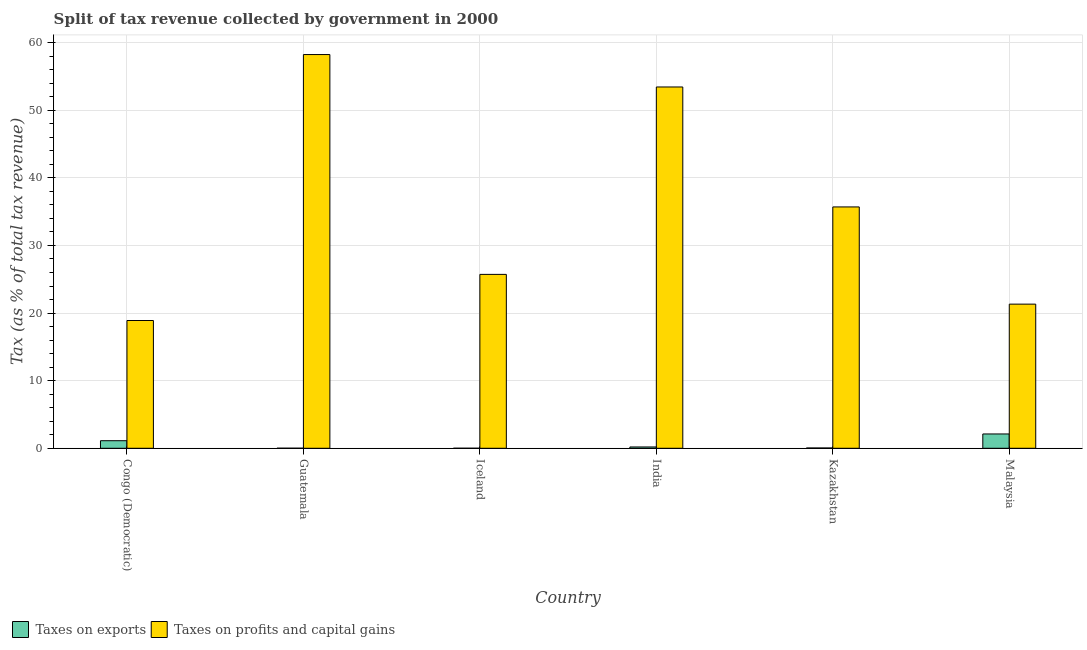Are the number of bars on each tick of the X-axis equal?
Give a very brief answer. Yes. How many bars are there on the 1st tick from the left?
Give a very brief answer. 2. What is the label of the 1st group of bars from the left?
Make the answer very short. Congo (Democratic). In how many cases, is the number of bars for a given country not equal to the number of legend labels?
Provide a short and direct response. 0. What is the percentage of revenue obtained from taxes on profits and capital gains in Kazakhstan?
Make the answer very short. 35.7. Across all countries, what is the maximum percentage of revenue obtained from taxes on profits and capital gains?
Your answer should be compact. 58.24. Across all countries, what is the minimum percentage of revenue obtained from taxes on profits and capital gains?
Your response must be concise. 18.9. In which country was the percentage of revenue obtained from taxes on profits and capital gains maximum?
Provide a succinct answer. Guatemala. In which country was the percentage of revenue obtained from taxes on profits and capital gains minimum?
Your response must be concise. Congo (Democratic). What is the total percentage of revenue obtained from taxes on profits and capital gains in the graph?
Your response must be concise. 213.34. What is the difference between the percentage of revenue obtained from taxes on exports in Guatemala and that in India?
Offer a terse response. -0.19. What is the difference between the percentage of revenue obtained from taxes on profits and capital gains in Kazakhstan and the percentage of revenue obtained from taxes on exports in Iceland?
Your response must be concise. 35.7. What is the average percentage of revenue obtained from taxes on exports per country?
Offer a very short reply. 0.58. What is the difference between the percentage of revenue obtained from taxes on profits and capital gains and percentage of revenue obtained from taxes on exports in Congo (Democratic)?
Keep it short and to the point. 17.78. What is the ratio of the percentage of revenue obtained from taxes on profits and capital gains in India to that in Kazakhstan?
Provide a short and direct response. 1.5. Is the difference between the percentage of revenue obtained from taxes on profits and capital gains in Guatemala and Malaysia greater than the difference between the percentage of revenue obtained from taxes on exports in Guatemala and Malaysia?
Give a very brief answer. Yes. What is the difference between the highest and the second highest percentage of revenue obtained from taxes on exports?
Ensure brevity in your answer.  1. What is the difference between the highest and the lowest percentage of revenue obtained from taxes on exports?
Provide a short and direct response. 2.11. What does the 2nd bar from the left in Iceland represents?
Give a very brief answer. Taxes on profits and capital gains. What does the 2nd bar from the right in Kazakhstan represents?
Ensure brevity in your answer.  Taxes on exports. What is the difference between two consecutive major ticks on the Y-axis?
Give a very brief answer. 10. Are the values on the major ticks of Y-axis written in scientific E-notation?
Offer a very short reply. No. Does the graph contain grids?
Provide a short and direct response. Yes. Where does the legend appear in the graph?
Your answer should be compact. Bottom left. How many legend labels are there?
Give a very brief answer. 2. How are the legend labels stacked?
Keep it short and to the point. Horizontal. What is the title of the graph?
Make the answer very short. Split of tax revenue collected by government in 2000. What is the label or title of the Y-axis?
Your answer should be compact. Tax (as % of total tax revenue). What is the Tax (as % of total tax revenue) of Taxes on exports in Congo (Democratic)?
Provide a succinct answer. 1.12. What is the Tax (as % of total tax revenue) in Taxes on profits and capital gains in Congo (Democratic)?
Provide a succinct answer. 18.9. What is the Tax (as % of total tax revenue) in Taxes on exports in Guatemala?
Offer a terse response. 0.01. What is the Tax (as % of total tax revenue) in Taxes on profits and capital gains in Guatemala?
Provide a short and direct response. 58.24. What is the Tax (as % of total tax revenue) in Taxes on exports in Iceland?
Keep it short and to the point. 0.01. What is the Tax (as % of total tax revenue) in Taxes on profits and capital gains in Iceland?
Your response must be concise. 25.72. What is the Tax (as % of total tax revenue) in Taxes on exports in India?
Provide a succinct answer. 0.2. What is the Tax (as % of total tax revenue) of Taxes on profits and capital gains in India?
Your response must be concise. 53.45. What is the Tax (as % of total tax revenue) of Taxes on exports in Kazakhstan?
Offer a very short reply. 0.05. What is the Tax (as % of total tax revenue) in Taxes on profits and capital gains in Kazakhstan?
Your response must be concise. 35.7. What is the Tax (as % of total tax revenue) of Taxes on exports in Malaysia?
Make the answer very short. 2.12. What is the Tax (as % of total tax revenue) of Taxes on profits and capital gains in Malaysia?
Make the answer very short. 21.32. Across all countries, what is the maximum Tax (as % of total tax revenue) of Taxes on exports?
Keep it short and to the point. 2.12. Across all countries, what is the maximum Tax (as % of total tax revenue) in Taxes on profits and capital gains?
Your answer should be very brief. 58.24. Across all countries, what is the minimum Tax (as % of total tax revenue) of Taxes on exports?
Provide a succinct answer. 0.01. Across all countries, what is the minimum Tax (as % of total tax revenue) in Taxes on profits and capital gains?
Provide a succinct answer. 18.9. What is the total Tax (as % of total tax revenue) of Taxes on exports in the graph?
Give a very brief answer. 3.5. What is the total Tax (as % of total tax revenue) of Taxes on profits and capital gains in the graph?
Make the answer very short. 213.34. What is the difference between the Tax (as % of total tax revenue) of Taxes on exports in Congo (Democratic) and that in Guatemala?
Your response must be concise. 1.11. What is the difference between the Tax (as % of total tax revenue) in Taxes on profits and capital gains in Congo (Democratic) and that in Guatemala?
Keep it short and to the point. -39.34. What is the difference between the Tax (as % of total tax revenue) in Taxes on exports in Congo (Democratic) and that in Iceland?
Ensure brevity in your answer.  1.11. What is the difference between the Tax (as % of total tax revenue) in Taxes on profits and capital gains in Congo (Democratic) and that in Iceland?
Provide a succinct answer. -6.82. What is the difference between the Tax (as % of total tax revenue) of Taxes on exports in Congo (Democratic) and that in India?
Make the answer very short. 0.92. What is the difference between the Tax (as % of total tax revenue) of Taxes on profits and capital gains in Congo (Democratic) and that in India?
Offer a terse response. -34.55. What is the difference between the Tax (as % of total tax revenue) of Taxes on exports in Congo (Democratic) and that in Kazakhstan?
Ensure brevity in your answer.  1.07. What is the difference between the Tax (as % of total tax revenue) of Taxes on profits and capital gains in Congo (Democratic) and that in Kazakhstan?
Ensure brevity in your answer.  -16.8. What is the difference between the Tax (as % of total tax revenue) of Taxes on exports in Congo (Democratic) and that in Malaysia?
Your answer should be very brief. -1. What is the difference between the Tax (as % of total tax revenue) in Taxes on profits and capital gains in Congo (Democratic) and that in Malaysia?
Provide a succinct answer. -2.42. What is the difference between the Tax (as % of total tax revenue) of Taxes on exports in Guatemala and that in Iceland?
Make the answer very short. 0. What is the difference between the Tax (as % of total tax revenue) of Taxes on profits and capital gains in Guatemala and that in Iceland?
Your response must be concise. 32.52. What is the difference between the Tax (as % of total tax revenue) of Taxes on exports in Guatemala and that in India?
Provide a short and direct response. -0.19. What is the difference between the Tax (as % of total tax revenue) in Taxes on profits and capital gains in Guatemala and that in India?
Your answer should be compact. 4.79. What is the difference between the Tax (as % of total tax revenue) in Taxes on exports in Guatemala and that in Kazakhstan?
Give a very brief answer. -0.04. What is the difference between the Tax (as % of total tax revenue) in Taxes on profits and capital gains in Guatemala and that in Kazakhstan?
Keep it short and to the point. 22.54. What is the difference between the Tax (as % of total tax revenue) in Taxes on exports in Guatemala and that in Malaysia?
Provide a succinct answer. -2.11. What is the difference between the Tax (as % of total tax revenue) of Taxes on profits and capital gains in Guatemala and that in Malaysia?
Offer a terse response. 36.92. What is the difference between the Tax (as % of total tax revenue) in Taxes on exports in Iceland and that in India?
Provide a succinct answer. -0.19. What is the difference between the Tax (as % of total tax revenue) of Taxes on profits and capital gains in Iceland and that in India?
Offer a terse response. -27.72. What is the difference between the Tax (as % of total tax revenue) of Taxes on exports in Iceland and that in Kazakhstan?
Give a very brief answer. -0.04. What is the difference between the Tax (as % of total tax revenue) of Taxes on profits and capital gains in Iceland and that in Kazakhstan?
Your answer should be compact. -9.98. What is the difference between the Tax (as % of total tax revenue) of Taxes on exports in Iceland and that in Malaysia?
Make the answer very short. -2.11. What is the difference between the Tax (as % of total tax revenue) in Taxes on profits and capital gains in Iceland and that in Malaysia?
Your answer should be very brief. 4.4. What is the difference between the Tax (as % of total tax revenue) of Taxes on exports in India and that in Kazakhstan?
Keep it short and to the point. 0.15. What is the difference between the Tax (as % of total tax revenue) of Taxes on profits and capital gains in India and that in Kazakhstan?
Your answer should be compact. 17.74. What is the difference between the Tax (as % of total tax revenue) of Taxes on exports in India and that in Malaysia?
Keep it short and to the point. -1.92. What is the difference between the Tax (as % of total tax revenue) in Taxes on profits and capital gains in India and that in Malaysia?
Your answer should be very brief. 32.12. What is the difference between the Tax (as % of total tax revenue) of Taxes on exports in Kazakhstan and that in Malaysia?
Ensure brevity in your answer.  -2.07. What is the difference between the Tax (as % of total tax revenue) in Taxes on profits and capital gains in Kazakhstan and that in Malaysia?
Make the answer very short. 14.38. What is the difference between the Tax (as % of total tax revenue) in Taxes on exports in Congo (Democratic) and the Tax (as % of total tax revenue) in Taxes on profits and capital gains in Guatemala?
Provide a short and direct response. -57.12. What is the difference between the Tax (as % of total tax revenue) of Taxes on exports in Congo (Democratic) and the Tax (as % of total tax revenue) of Taxes on profits and capital gains in Iceland?
Your answer should be compact. -24.61. What is the difference between the Tax (as % of total tax revenue) of Taxes on exports in Congo (Democratic) and the Tax (as % of total tax revenue) of Taxes on profits and capital gains in India?
Your response must be concise. -52.33. What is the difference between the Tax (as % of total tax revenue) of Taxes on exports in Congo (Democratic) and the Tax (as % of total tax revenue) of Taxes on profits and capital gains in Kazakhstan?
Make the answer very short. -34.58. What is the difference between the Tax (as % of total tax revenue) in Taxes on exports in Congo (Democratic) and the Tax (as % of total tax revenue) in Taxes on profits and capital gains in Malaysia?
Your answer should be compact. -20.2. What is the difference between the Tax (as % of total tax revenue) in Taxes on exports in Guatemala and the Tax (as % of total tax revenue) in Taxes on profits and capital gains in Iceland?
Provide a short and direct response. -25.72. What is the difference between the Tax (as % of total tax revenue) in Taxes on exports in Guatemala and the Tax (as % of total tax revenue) in Taxes on profits and capital gains in India?
Make the answer very short. -53.44. What is the difference between the Tax (as % of total tax revenue) of Taxes on exports in Guatemala and the Tax (as % of total tax revenue) of Taxes on profits and capital gains in Kazakhstan?
Ensure brevity in your answer.  -35.69. What is the difference between the Tax (as % of total tax revenue) in Taxes on exports in Guatemala and the Tax (as % of total tax revenue) in Taxes on profits and capital gains in Malaysia?
Offer a terse response. -21.31. What is the difference between the Tax (as % of total tax revenue) in Taxes on exports in Iceland and the Tax (as % of total tax revenue) in Taxes on profits and capital gains in India?
Ensure brevity in your answer.  -53.44. What is the difference between the Tax (as % of total tax revenue) in Taxes on exports in Iceland and the Tax (as % of total tax revenue) in Taxes on profits and capital gains in Kazakhstan?
Ensure brevity in your answer.  -35.7. What is the difference between the Tax (as % of total tax revenue) in Taxes on exports in Iceland and the Tax (as % of total tax revenue) in Taxes on profits and capital gains in Malaysia?
Keep it short and to the point. -21.32. What is the difference between the Tax (as % of total tax revenue) in Taxes on exports in India and the Tax (as % of total tax revenue) in Taxes on profits and capital gains in Kazakhstan?
Keep it short and to the point. -35.51. What is the difference between the Tax (as % of total tax revenue) of Taxes on exports in India and the Tax (as % of total tax revenue) of Taxes on profits and capital gains in Malaysia?
Your answer should be very brief. -21.13. What is the difference between the Tax (as % of total tax revenue) of Taxes on exports in Kazakhstan and the Tax (as % of total tax revenue) of Taxes on profits and capital gains in Malaysia?
Provide a short and direct response. -21.28. What is the average Tax (as % of total tax revenue) in Taxes on exports per country?
Offer a very short reply. 0.58. What is the average Tax (as % of total tax revenue) in Taxes on profits and capital gains per country?
Your answer should be very brief. 35.56. What is the difference between the Tax (as % of total tax revenue) of Taxes on exports and Tax (as % of total tax revenue) of Taxes on profits and capital gains in Congo (Democratic)?
Give a very brief answer. -17.78. What is the difference between the Tax (as % of total tax revenue) in Taxes on exports and Tax (as % of total tax revenue) in Taxes on profits and capital gains in Guatemala?
Offer a terse response. -58.23. What is the difference between the Tax (as % of total tax revenue) of Taxes on exports and Tax (as % of total tax revenue) of Taxes on profits and capital gains in Iceland?
Give a very brief answer. -25.72. What is the difference between the Tax (as % of total tax revenue) of Taxes on exports and Tax (as % of total tax revenue) of Taxes on profits and capital gains in India?
Your answer should be very brief. -53.25. What is the difference between the Tax (as % of total tax revenue) in Taxes on exports and Tax (as % of total tax revenue) in Taxes on profits and capital gains in Kazakhstan?
Keep it short and to the point. -35.66. What is the difference between the Tax (as % of total tax revenue) of Taxes on exports and Tax (as % of total tax revenue) of Taxes on profits and capital gains in Malaysia?
Make the answer very short. -19.2. What is the ratio of the Tax (as % of total tax revenue) of Taxes on exports in Congo (Democratic) to that in Guatemala?
Offer a terse response. 113.15. What is the ratio of the Tax (as % of total tax revenue) in Taxes on profits and capital gains in Congo (Democratic) to that in Guatemala?
Your answer should be compact. 0.32. What is the ratio of the Tax (as % of total tax revenue) of Taxes on exports in Congo (Democratic) to that in Iceland?
Your answer should be compact. 166.06. What is the ratio of the Tax (as % of total tax revenue) of Taxes on profits and capital gains in Congo (Democratic) to that in Iceland?
Provide a short and direct response. 0.73. What is the ratio of the Tax (as % of total tax revenue) of Taxes on exports in Congo (Democratic) to that in India?
Make the answer very short. 5.73. What is the ratio of the Tax (as % of total tax revenue) of Taxes on profits and capital gains in Congo (Democratic) to that in India?
Keep it short and to the point. 0.35. What is the ratio of the Tax (as % of total tax revenue) in Taxes on exports in Congo (Democratic) to that in Kazakhstan?
Offer a terse response. 24.63. What is the ratio of the Tax (as % of total tax revenue) in Taxes on profits and capital gains in Congo (Democratic) to that in Kazakhstan?
Ensure brevity in your answer.  0.53. What is the ratio of the Tax (as % of total tax revenue) in Taxes on exports in Congo (Democratic) to that in Malaysia?
Keep it short and to the point. 0.53. What is the ratio of the Tax (as % of total tax revenue) in Taxes on profits and capital gains in Congo (Democratic) to that in Malaysia?
Provide a succinct answer. 0.89. What is the ratio of the Tax (as % of total tax revenue) of Taxes on exports in Guatemala to that in Iceland?
Your response must be concise. 1.47. What is the ratio of the Tax (as % of total tax revenue) in Taxes on profits and capital gains in Guatemala to that in Iceland?
Your response must be concise. 2.26. What is the ratio of the Tax (as % of total tax revenue) in Taxes on exports in Guatemala to that in India?
Your response must be concise. 0.05. What is the ratio of the Tax (as % of total tax revenue) of Taxes on profits and capital gains in Guatemala to that in India?
Give a very brief answer. 1.09. What is the ratio of the Tax (as % of total tax revenue) of Taxes on exports in Guatemala to that in Kazakhstan?
Make the answer very short. 0.22. What is the ratio of the Tax (as % of total tax revenue) in Taxes on profits and capital gains in Guatemala to that in Kazakhstan?
Make the answer very short. 1.63. What is the ratio of the Tax (as % of total tax revenue) of Taxes on exports in Guatemala to that in Malaysia?
Ensure brevity in your answer.  0. What is the ratio of the Tax (as % of total tax revenue) of Taxes on profits and capital gains in Guatemala to that in Malaysia?
Your answer should be compact. 2.73. What is the ratio of the Tax (as % of total tax revenue) of Taxes on exports in Iceland to that in India?
Give a very brief answer. 0.03. What is the ratio of the Tax (as % of total tax revenue) of Taxes on profits and capital gains in Iceland to that in India?
Your response must be concise. 0.48. What is the ratio of the Tax (as % of total tax revenue) of Taxes on exports in Iceland to that in Kazakhstan?
Offer a very short reply. 0.15. What is the ratio of the Tax (as % of total tax revenue) of Taxes on profits and capital gains in Iceland to that in Kazakhstan?
Provide a short and direct response. 0.72. What is the ratio of the Tax (as % of total tax revenue) in Taxes on exports in Iceland to that in Malaysia?
Make the answer very short. 0. What is the ratio of the Tax (as % of total tax revenue) in Taxes on profits and capital gains in Iceland to that in Malaysia?
Offer a very short reply. 1.21. What is the ratio of the Tax (as % of total tax revenue) of Taxes on exports in India to that in Kazakhstan?
Your answer should be very brief. 4.3. What is the ratio of the Tax (as % of total tax revenue) in Taxes on profits and capital gains in India to that in Kazakhstan?
Keep it short and to the point. 1.5. What is the ratio of the Tax (as % of total tax revenue) of Taxes on exports in India to that in Malaysia?
Your answer should be very brief. 0.09. What is the ratio of the Tax (as % of total tax revenue) in Taxes on profits and capital gains in India to that in Malaysia?
Your response must be concise. 2.51. What is the ratio of the Tax (as % of total tax revenue) of Taxes on exports in Kazakhstan to that in Malaysia?
Give a very brief answer. 0.02. What is the ratio of the Tax (as % of total tax revenue) in Taxes on profits and capital gains in Kazakhstan to that in Malaysia?
Make the answer very short. 1.67. What is the difference between the highest and the second highest Tax (as % of total tax revenue) of Taxes on exports?
Offer a terse response. 1. What is the difference between the highest and the second highest Tax (as % of total tax revenue) in Taxes on profits and capital gains?
Your response must be concise. 4.79. What is the difference between the highest and the lowest Tax (as % of total tax revenue) in Taxes on exports?
Make the answer very short. 2.11. What is the difference between the highest and the lowest Tax (as % of total tax revenue) in Taxes on profits and capital gains?
Your answer should be very brief. 39.34. 